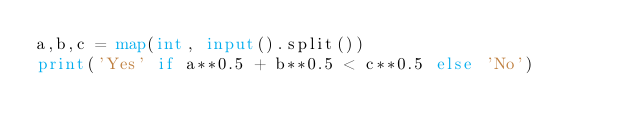Convert code to text. <code><loc_0><loc_0><loc_500><loc_500><_Python_>a,b,c = map(int, input().split())
print('Yes' if a**0.5 + b**0.5 < c**0.5 else 'No')</code> 